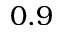<formula> <loc_0><loc_0><loc_500><loc_500>0 . 9</formula> 